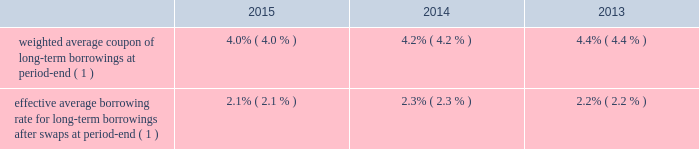Morgan stanley notes to consolidated financial statements 2014 ( continued ) senior debt securities often are denominated in various non-u.s .
Dollar currencies and may be structured to provide a return that is equity-linked , credit-linked , commodity-linked or linked to some other index ( e.g. , the consumer price index ) .
Senior debt also may be structured to be callable by the company or extendible at the option of holders of the senior debt securities .
Debt containing provisions that effectively allow the holders to put or extend the notes aggregated $ 2902 million at december 31 , 2015 and $ 2175 million at december 31 , 2014 .
In addition , in certain circumstances , certain purchasers may be entitled to cause the repurchase of the notes .
The aggregated value of notes subject to these arrangements was $ 650 million at december 31 , 2015 and $ 551 million at december 31 , 2014 .
Subordinated debt and junior subordinated debentures generally are issued to meet the capital requirements of the company or its regulated subsidiaries and primarily are u.s .
Dollar denominated .
During 2015 , morgan stanley capital trusts vi and vii redeemed all of their issued and outstanding 6.60% ( 6.60 % ) capital securities , respectively , and the company concurrently redeemed the related underlying junior subordinated debentures .
Senior debt 2014structured borrowings .
The company 2019s index-linked , equity-linked or credit-linked borrowings include various structured instruments whose payments and redemption values are linked to the performance of a specific index ( e.g. , standard & poor 2019s 500 ) , a basket of stocks , a specific equity security , a credit exposure or basket of credit exposures .
To minimize the exposure resulting from movements in the underlying index , equity , credit or other position , the company has entered into various swap contracts and purchased options that effectively convert the borrowing costs into floating rates based upon libor .
The company generally carries the entire structured borrowings at fair value .
The swaps and purchased options used to economically hedge the embedded features are derivatives and also are carried at fair value .
Changes in fair value related to the notes and economic hedges are reported in trading revenues .
See note 3 for further information on structured borrowings .
Subordinated debt and junior subordinated debentures .
Included in the long-term borrowings are subordinated notes of $ 10404 million having a contractual weighted average coupon of 4.45% ( 4.45 % ) at december 31 , 2015 and $ 8339 million having a contractual weighted average coupon of 4.57% ( 4.57 % ) at december 31 , 2014 .
Junior subordinated debentures outstanding by the company were $ 2870 million at december 31 , 2015 having a contractual weighted average coupon of 6.22% ( 6.22 % ) at december 31 , 2015 and $ 4868 million at december 31 , 2014 having a contractual weighted average coupon of 6.37% ( 6.37 % ) at december 31 , 2014 .
Maturities of the subordinated and junior subordinated notes range from 2022 to 2067 , while maturities of certain junior subordinated debentures can be extended to 2052 at the company 2019s option .
Asset and liability management .
In general , securities inventories that are not financed by secured funding sources and the majority of the company 2019s assets are financed with a combination of deposits , short-term funding , floating rate long-term debt or fixed rate long-term debt swapped to a floating rate .
Fixed assets are generally financed with fixed rate long-term debt .
The company uses interest rate swaps to more closely match these borrowings to the duration , holding period and interest rate characteristics of the assets being funded and to manage interest rate risk .
These swaps effectively convert certain of the company 2019s fixed rate borrowings into floating rate obligations .
In addition , for non-u.s .
Dollar currency borrowings that are not used to fund assets in the same currency , the company has entered into currency swaps that effectively convert the borrowings into u.s .
Dollar obligations .
The company 2019s use of swaps for asset and liability management affected its effective average borrowing rate .
Effective average borrowing rate. .

What is the difference in effective borrowing rate in 2015 due to the use of swaps? 
Computations: (4 - 2.1)
Answer: 1.9. 